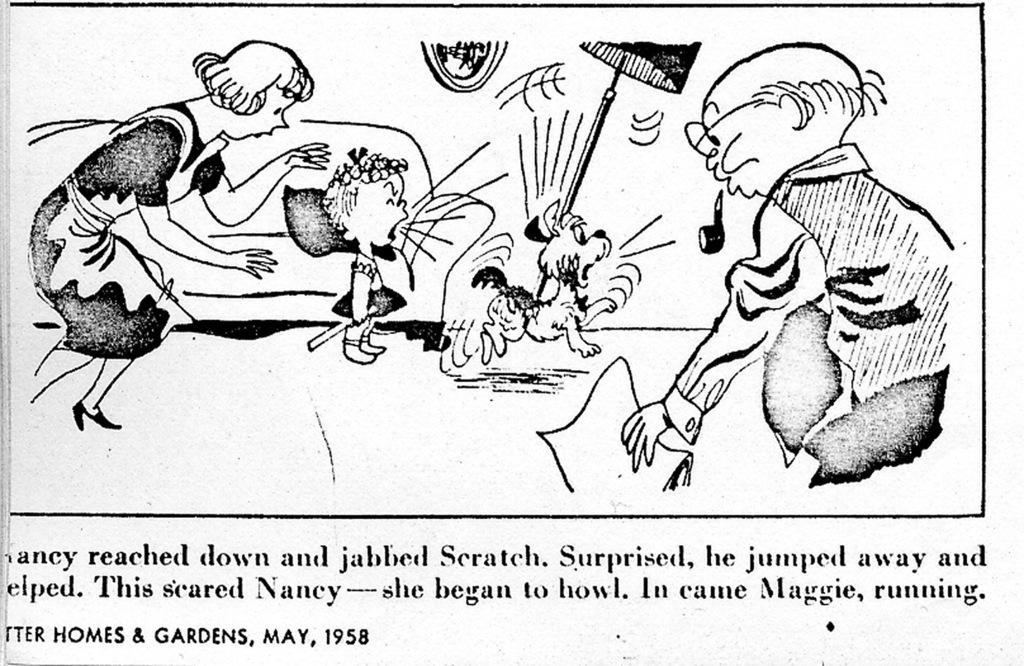Please provide a concise description of this image. We can see images and something written on this poster. 